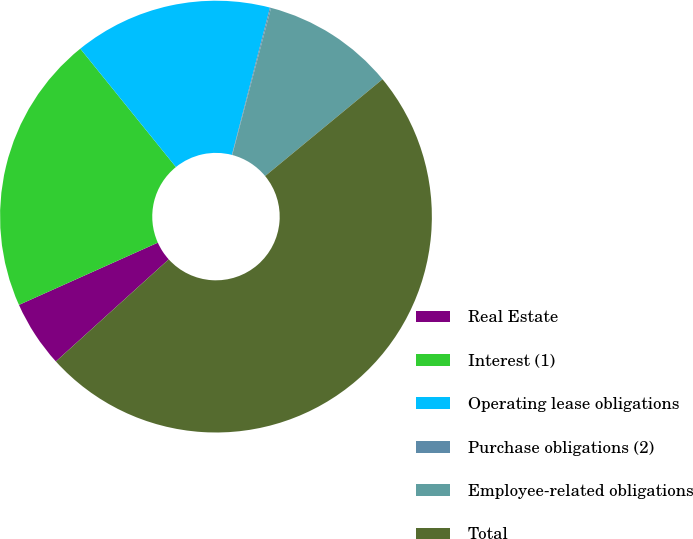Convert chart. <chart><loc_0><loc_0><loc_500><loc_500><pie_chart><fcel>Real Estate<fcel>Interest (1)<fcel>Operating lease obligations<fcel>Purchase obligations (2)<fcel>Employee-related obligations<fcel>Total<nl><fcel>5.0%<fcel>20.89%<fcel>14.84%<fcel>0.08%<fcel>9.92%<fcel>49.27%<nl></chart> 